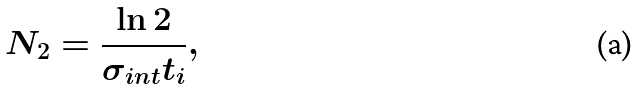Convert formula to latex. <formula><loc_0><loc_0><loc_500><loc_500>N _ { 2 } = \frac { \ln 2 } { \sigma _ { i n t } t _ { i } } ,</formula> 